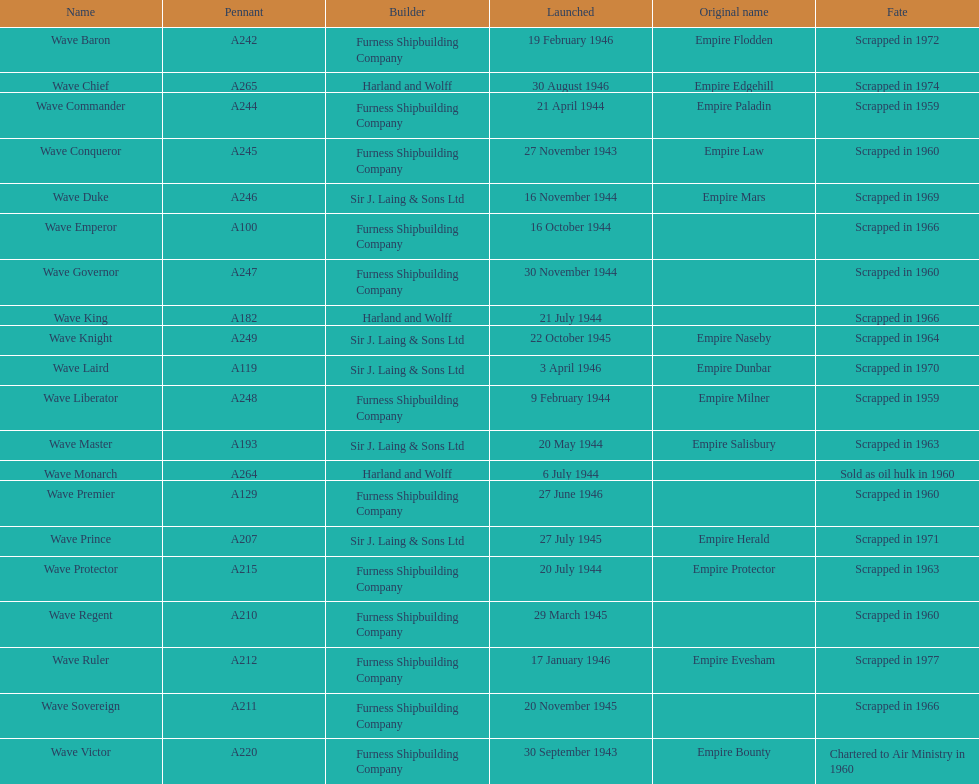Following the wave emperor, which wave-class oiler came next? Wave Duke. 